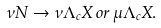Convert formula to latex. <formula><loc_0><loc_0><loc_500><loc_500>\nu N \rightarrow \nu \Lambda _ { c } X \, o r \, \mu \Lambda _ { c } X .</formula> 